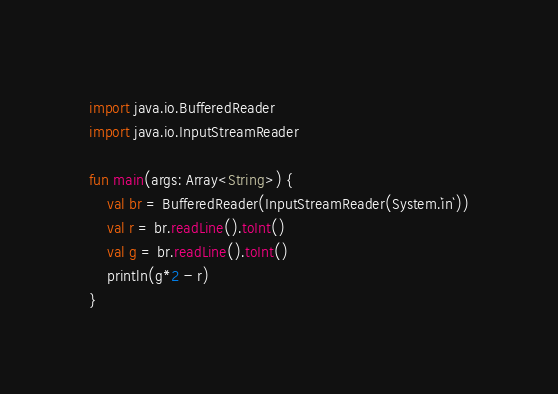Convert code to text. <code><loc_0><loc_0><loc_500><loc_500><_Kotlin_>import java.io.BufferedReader
import java.io.InputStreamReader

fun main(args: Array<String>) {
    val br = BufferedReader(InputStreamReader(System.`in`))
    val r = br.readLine().toInt()
    val g = br.readLine().toInt()
    println(g*2 - r)
}
</code> 